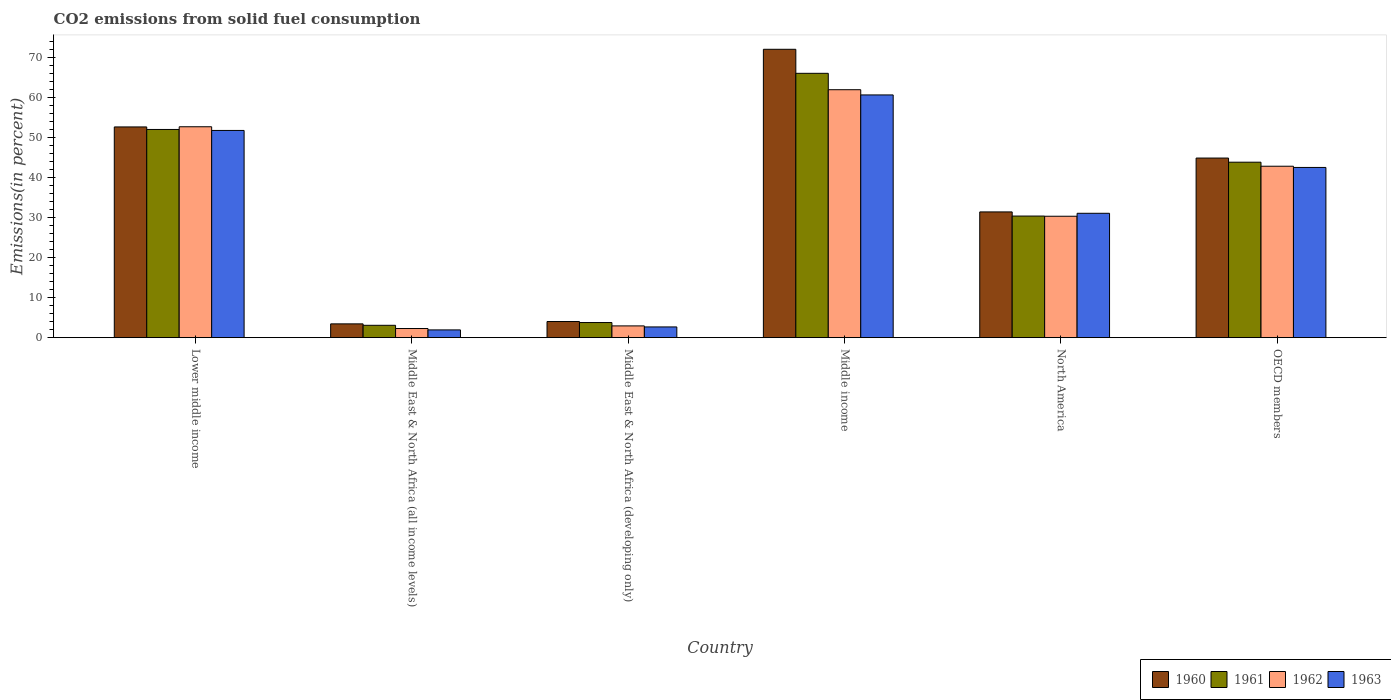How many different coloured bars are there?
Your answer should be very brief. 4. How many groups of bars are there?
Provide a short and direct response. 6. How many bars are there on the 5th tick from the left?
Provide a succinct answer. 4. How many bars are there on the 1st tick from the right?
Your response must be concise. 4. What is the label of the 5th group of bars from the left?
Provide a short and direct response. North America. In how many cases, is the number of bars for a given country not equal to the number of legend labels?
Make the answer very short. 0. What is the total CO2 emitted in 1962 in Middle income?
Make the answer very short. 61.92. Across all countries, what is the maximum total CO2 emitted in 1960?
Offer a very short reply. 72.02. Across all countries, what is the minimum total CO2 emitted in 1960?
Provide a succinct answer. 3.44. In which country was the total CO2 emitted in 1963 minimum?
Ensure brevity in your answer.  Middle East & North Africa (all income levels). What is the total total CO2 emitted in 1961 in the graph?
Ensure brevity in your answer.  199.06. What is the difference between the total CO2 emitted in 1960 in Lower middle income and that in North America?
Make the answer very short. 21.22. What is the difference between the total CO2 emitted in 1962 in Lower middle income and the total CO2 emitted in 1961 in North America?
Make the answer very short. 22.3. What is the average total CO2 emitted in 1961 per country?
Your answer should be compact. 33.18. What is the difference between the total CO2 emitted of/in 1963 and total CO2 emitted of/in 1962 in North America?
Your answer should be very brief. 0.74. In how many countries, is the total CO2 emitted in 1963 greater than 58 %?
Keep it short and to the point. 1. What is the ratio of the total CO2 emitted in 1963 in Middle East & North Africa (all income levels) to that in Middle income?
Your response must be concise. 0.03. Is the total CO2 emitted in 1962 in Lower middle income less than that in OECD members?
Offer a terse response. No. Is the difference between the total CO2 emitted in 1963 in Lower middle income and Middle East & North Africa (all income levels) greater than the difference between the total CO2 emitted in 1962 in Lower middle income and Middle East & North Africa (all income levels)?
Your response must be concise. No. What is the difference between the highest and the second highest total CO2 emitted in 1960?
Your response must be concise. 19.39. What is the difference between the highest and the lowest total CO2 emitted in 1961?
Give a very brief answer. 62.93. Is the sum of the total CO2 emitted in 1961 in Middle income and OECD members greater than the maximum total CO2 emitted in 1960 across all countries?
Ensure brevity in your answer.  Yes. What does the 2nd bar from the left in Lower middle income represents?
Your response must be concise. 1961. What does the 2nd bar from the right in OECD members represents?
Provide a short and direct response. 1962. How many bars are there?
Your answer should be very brief. 24. Are all the bars in the graph horizontal?
Give a very brief answer. No. How many countries are there in the graph?
Provide a short and direct response. 6. What is the difference between two consecutive major ticks on the Y-axis?
Keep it short and to the point. 10. How are the legend labels stacked?
Provide a succinct answer. Horizontal. What is the title of the graph?
Ensure brevity in your answer.  CO2 emissions from solid fuel consumption. What is the label or title of the X-axis?
Offer a very short reply. Country. What is the label or title of the Y-axis?
Give a very brief answer. Emissions(in percent). What is the Emissions(in percent) of 1960 in Lower middle income?
Your answer should be compact. 52.63. What is the Emissions(in percent) in 1961 in Lower middle income?
Your answer should be very brief. 51.99. What is the Emissions(in percent) of 1962 in Lower middle income?
Offer a terse response. 52.67. What is the Emissions(in percent) of 1963 in Lower middle income?
Give a very brief answer. 51.75. What is the Emissions(in percent) of 1960 in Middle East & North Africa (all income levels)?
Your answer should be very brief. 3.44. What is the Emissions(in percent) in 1961 in Middle East & North Africa (all income levels)?
Make the answer very short. 3.09. What is the Emissions(in percent) of 1962 in Middle East & North Africa (all income levels)?
Offer a terse response. 2.28. What is the Emissions(in percent) of 1963 in Middle East & North Africa (all income levels)?
Ensure brevity in your answer.  1.94. What is the Emissions(in percent) of 1960 in Middle East & North Africa (developing only)?
Provide a short and direct response. 4.03. What is the Emissions(in percent) of 1961 in Middle East & North Africa (developing only)?
Give a very brief answer. 3.78. What is the Emissions(in percent) in 1962 in Middle East & North Africa (developing only)?
Provide a succinct answer. 2.94. What is the Emissions(in percent) of 1963 in Middle East & North Africa (developing only)?
Offer a very short reply. 2.68. What is the Emissions(in percent) of 1960 in Middle income?
Your answer should be compact. 72.02. What is the Emissions(in percent) of 1961 in Middle income?
Provide a short and direct response. 66.02. What is the Emissions(in percent) in 1962 in Middle income?
Keep it short and to the point. 61.92. What is the Emissions(in percent) of 1963 in Middle income?
Your answer should be very brief. 60.62. What is the Emissions(in percent) of 1960 in North America?
Give a very brief answer. 31.4. What is the Emissions(in percent) of 1961 in North America?
Provide a short and direct response. 30.37. What is the Emissions(in percent) in 1962 in North America?
Make the answer very short. 30.32. What is the Emissions(in percent) in 1963 in North America?
Provide a short and direct response. 31.06. What is the Emissions(in percent) of 1960 in OECD members?
Offer a very short reply. 44.86. What is the Emissions(in percent) of 1961 in OECD members?
Make the answer very short. 43.82. What is the Emissions(in percent) in 1962 in OECD members?
Offer a terse response. 42.82. What is the Emissions(in percent) in 1963 in OECD members?
Your answer should be compact. 42.51. Across all countries, what is the maximum Emissions(in percent) in 1960?
Offer a terse response. 72.02. Across all countries, what is the maximum Emissions(in percent) of 1961?
Provide a short and direct response. 66.02. Across all countries, what is the maximum Emissions(in percent) of 1962?
Offer a terse response. 61.92. Across all countries, what is the maximum Emissions(in percent) in 1963?
Ensure brevity in your answer.  60.62. Across all countries, what is the minimum Emissions(in percent) of 1960?
Keep it short and to the point. 3.44. Across all countries, what is the minimum Emissions(in percent) in 1961?
Keep it short and to the point. 3.09. Across all countries, what is the minimum Emissions(in percent) in 1962?
Give a very brief answer. 2.28. Across all countries, what is the minimum Emissions(in percent) of 1963?
Your answer should be very brief. 1.94. What is the total Emissions(in percent) of 1960 in the graph?
Ensure brevity in your answer.  208.38. What is the total Emissions(in percent) of 1961 in the graph?
Provide a succinct answer. 199.06. What is the total Emissions(in percent) of 1962 in the graph?
Offer a terse response. 192.96. What is the total Emissions(in percent) in 1963 in the graph?
Provide a short and direct response. 190.56. What is the difference between the Emissions(in percent) in 1960 in Lower middle income and that in Middle East & North Africa (all income levels)?
Your answer should be very brief. 49.18. What is the difference between the Emissions(in percent) in 1961 in Lower middle income and that in Middle East & North Africa (all income levels)?
Your answer should be compact. 48.91. What is the difference between the Emissions(in percent) of 1962 in Lower middle income and that in Middle East & North Africa (all income levels)?
Your answer should be compact. 50.39. What is the difference between the Emissions(in percent) of 1963 in Lower middle income and that in Middle East & North Africa (all income levels)?
Your response must be concise. 49.81. What is the difference between the Emissions(in percent) in 1960 in Lower middle income and that in Middle East & North Africa (developing only)?
Your answer should be very brief. 48.6. What is the difference between the Emissions(in percent) of 1961 in Lower middle income and that in Middle East & North Africa (developing only)?
Keep it short and to the point. 48.22. What is the difference between the Emissions(in percent) of 1962 in Lower middle income and that in Middle East & North Africa (developing only)?
Make the answer very short. 49.73. What is the difference between the Emissions(in percent) in 1963 in Lower middle income and that in Middle East & North Africa (developing only)?
Provide a short and direct response. 49.07. What is the difference between the Emissions(in percent) in 1960 in Lower middle income and that in Middle income?
Provide a short and direct response. -19.39. What is the difference between the Emissions(in percent) of 1961 in Lower middle income and that in Middle income?
Make the answer very short. -14.02. What is the difference between the Emissions(in percent) of 1962 in Lower middle income and that in Middle income?
Provide a succinct answer. -9.25. What is the difference between the Emissions(in percent) of 1963 in Lower middle income and that in Middle income?
Your answer should be very brief. -8.87. What is the difference between the Emissions(in percent) of 1960 in Lower middle income and that in North America?
Your response must be concise. 21.22. What is the difference between the Emissions(in percent) of 1961 in Lower middle income and that in North America?
Offer a very short reply. 21.63. What is the difference between the Emissions(in percent) in 1962 in Lower middle income and that in North America?
Keep it short and to the point. 22.35. What is the difference between the Emissions(in percent) of 1963 in Lower middle income and that in North America?
Ensure brevity in your answer.  20.69. What is the difference between the Emissions(in percent) of 1960 in Lower middle income and that in OECD members?
Make the answer very short. 7.77. What is the difference between the Emissions(in percent) of 1961 in Lower middle income and that in OECD members?
Offer a terse response. 8.17. What is the difference between the Emissions(in percent) of 1962 in Lower middle income and that in OECD members?
Ensure brevity in your answer.  9.86. What is the difference between the Emissions(in percent) of 1963 in Lower middle income and that in OECD members?
Provide a succinct answer. 9.24. What is the difference between the Emissions(in percent) in 1960 in Middle East & North Africa (all income levels) and that in Middle East & North Africa (developing only)?
Provide a short and direct response. -0.59. What is the difference between the Emissions(in percent) of 1961 in Middle East & North Africa (all income levels) and that in Middle East & North Africa (developing only)?
Make the answer very short. -0.69. What is the difference between the Emissions(in percent) of 1962 in Middle East & North Africa (all income levels) and that in Middle East & North Africa (developing only)?
Your response must be concise. -0.65. What is the difference between the Emissions(in percent) of 1963 in Middle East & North Africa (all income levels) and that in Middle East & North Africa (developing only)?
Your answer should be very brief. -0.74. What is the difference between the Emissions(in percent) of 1960 in Middle East & North Africa (all income levels) and that in Middle income?
Offer a terse response. -68.57. What is the difference between the Emissions(in percent) of 1961 in Middle East & North Africa (all income levels) and that in Middle income?
Your response must be concise. -62.93. What is the difference between the Emissions(in percent) of 1962 in Middle East & North Africa (all income levels) and that in Middle income?
Give a very brief answer. -59.64. What is the difference between the Emissions(in percent) in 1963 in Middle East & North Africa (all income levels) and that in Middle income?
Keep it short and to the point. -58.68. What is the difference between the Emissions(in percent) of 1960 in Middle East & North Africa (all income levels) and that in North America?
Your answer should be compact. -27.96. What is the difference between the Emissions(in percent) of 1961 in Middle East & North Africa (all income levels) and that in North America?
Offer a terse response. -27.28. What is the difference between the Emissions(in percent) in 1962 in Middle East & North Africa (all income levels) and that in North America?
Your response must be concise. -28.04. What is the difference between the Emissions(in percent) in 1963 in Middle East & North Africa (all income levels) and that in North America?
Offer a terse response. -29.12. What is the difference between the Emissions(in percent) of 1960 in Middle East & North Africa (all income levels) and that in OECD members?
Your answer should be very brief. -41.41. What is the difference between the Emissions(in percent) of 1961 in Middle East & North Africa (all income levels) and that in OECD members?
Offer a terse response. -40.74. What is the difference between the Emissions(in percent) in 1962 in Middle East & North Africa (all income levels) and that in OECD members?
Keep it short and to the point. -40.53. What is the difference between the Emissions(in percent) in 1963 in Middle East & North Africa (all income levels) and that in OECD members?
Provide a short and direct response. -40.57. What is the difference between the Emissions(in percent) in 1960 in Middle East & North Africa (developing only) and that in Middle income?
Ensure brevity in your answer.  -67.99. What is the difference between the Emissions(in percent) of 1961 in Middle East & North Africa (developing only) and that in Middle income?
Offer a very short reply. -62.24. What is the difference between the Emissions(in percent) in 1962 in Middle East & North Africa (developing only) and that in Middle income?
Make the answer very short. -58.99. What is the difference between the Emissions(in percent) of 1963 in Middle East & North Africa (developing only) and that in Middle income?
Your answer should be very brief. -57.94. What is the difference between the Emissions(in percent) in 1960 in Middle East & North Africa (developing only) and that in North America?
Provide a succinct answer. -27.37. What is the difference between the Emissions(in percent) of 1961 in Middle East & North Africa (developing only) and that in North America?
Offer a terse response. -26.59. What is the difference between the Emissions(in percent) in 1962 in Middle East & North Africa (developing only) and that in North America?
Ensure brevity in your answer.  -27.38. What is the difference between the Emissions(in percent) in 1963 in Middle East & North Africa (developing only) and that in North America?
Offer a very short reply. -28.38. What is the difference between the Emissions(in percent) of 1960 in Middle East & North Africa (developing only) and that in OECD members?
Provide a succinct answer. -40.82. What is the difference between the Emissions(in percent) in 1961 in Middle East & North Africa (developing only) and that in OECD members?
Your answer should be compact. -40.05. What is the difference between the Emissions(in percent) of 1962 in Middle East & North Africa (developing only) and that in OECD members?
Your response must be concise. -39.88. What is the difference between the Emissions(in percent) in 1963 in Middle East & North Africa (developing only) and that in OECD members?
Give a very brief answer. -39.83. What is the difference between the Emissions(in percent) of 1960 in Middle income and that in North America?
Your answer should be very brief. 40.61. What is the difference between the Emissions(in percent) in 1961 in Middle income and that in North America?
Provide a short and direct response. 35.65. What is the difference between the Emissions(in percent) of 1962 in Middle income and that in North America?
Provide a short and direct response. 31.6. What is the difference between the Emissions(in percent) of 1963 in Middle income and that in North America?
Your answer should be very brief. 29.56. What is the difference between the Emissions(in percent) of 1960 in Middle income and that in OECD members?
Your response must be concise. 27.16. What is the difference between the Emissions(in percent) in 1961 in Middle income and that in OECD members?
Your answer should be compact. 22.2. What is the difference between the Emissions(in percent) in 1962 in Middle income and that in OECD members?
Offer a very short reply. 19.11. What is the difference between the Emissions(in percent) in 1963 in Middle income and that in OECD members?
Offer a very short reply. 18.11. What is the difference between the Emissions(in percent) in 1960 in North America and that in OECD members?
Provide a short and direct response. -13.45. What is the difference between the Emissions(in percent) of 1961 in North America and that in OECD members?
Give a very brief answer. -13.45. What is the difference between the Emissions(in percent) of 1962 in North America and that in OECD members?
Provide a succinct answer. -12.49. What is the difference between the Emissions(in percent) of 1963 in North America and that in OECD members?
Keep it short and to the point. -11.45. What is the difference between the Emissions(in percent) of 1960 in Lower middle income and the Emissions(in percent) of 1961 in Middle East & North Africa (all income levels)?
Give a very brief answer. 49.54. What is the difference between the Emissions(in percent) of 1960 in Lower middle income and the Emissions(in percent) of 1962 in Middle East & North Africa (all income levels)?
Provide a short and direct response. 50.34. What is the difference between the Emissions(in percent) of 1960 in Lower middle income and the Emissions(in percent) of 1963 in Middle East & North Africa (all income levels)?
Your response must be concise. 50.69. What is the difference between the Emissions(in percent) in 1961 in Lower middle income and the Emissions(in percent) in 1962 in Middle East & North Africa (all income levels)?
Your response must be concise. 49.71. What is the difference between the Emissions(in percent) of 1961 in Lower middle income and the Emissions(in percent) of 1963 in Middle East & North Africa (all income levels)?
Keep it short and to the point. 50.06. What is the difference between the Emissions(in percent) in 1962 in Lower middle income and the Emissions(in percent) in 1963 in Middle East & North Africa (all income levels)?
Offer a very short reply. 50.74. What is the difference between the Emissions(in percent) of 1960 in Lower middle income and the Emissions(in percent) of 1961 in Middle East & North Africa (developing only)?
Ensure brevity in your answer.  48.85. What is the difference between the Emissions(in percent) of 1960 in Lower middle income and the Emissions(in percent) of 1962 in Middle East & North Africa (developing only)?
Your answer should be very brief. 49.69. What is the difference between the Emissions(in percent) of 1960 in Lower middle income and the Emissions(in percent) of 1963 in Middle East & North Africa (developing only)?
Provide a short and direct response. 49.95. What is the difference between the Emissions(in percent) in 1961 in Lower middle income and the Emissions(in percent) in 1962 in Middle East & North Africa (developing only)?
Provide a succinct answer. 49.06. What is the difference between the Emissions(in percent) in 1961 in Lower middle income and the Emissions(in percent) in 1963 in Middle East & North Africa (developing only)?
Make the answer very short. 49.32. What is the difference between the Emissions(in percent) in 1962 in Lower middle income and the Emissions(in percent) in 1963 in Middle East & North Africa (developing only)?
Provide a succinct answer. 49.99. What is the difference between the Emissions(in percent) of 1960 in Lower middle income and the Emissions(in percent) of 1961 in Middle income?
Your answer should be compact. -13.39. What is the difference between the Emissions(in percent) of 1960 in Lower middle income and the Emissions(in percent) of 1962 in Middle income?
Provide a succinct answer. -9.3. What is the difference between the Emissions(in percent) of 1960 in Lower middle income and the Emissions(in percent) of 1963 in Middle income?
Offer a terse response. -7.99. What is the difference between the Emissions(in percent) in 1961 in Lower middle income and the Emissions(in percent) in 1962 in Middle income?
Offer a terse response. -9.93. What is the difference between the Emissions(in percent) of 1961 in Lower middle income and the Emissions(in percent) of 1963 in Middle income?
Offer a terse response. -8.62. What is the difference between the Emissions(in percent) of 1962 in Lower middle income and the Emissions(in percent) of 1963 in Middle income?
Provide a succinct answer. -7.95. What is the difference between the Emissions(in percent) of 1960 in Lower middle income and the Emissions(in percent) of 1961 in North America?
Give a very brief answer. 22.26. What is the difference between the Emissions(in percent) in 1960 in Lower middle income and the Emissions(in percent) in 1962 in North America?
Provide a succinct answer. 22.31. What is the difference between the Emissions(in percent) of 1960 in Lower middle income and the Emissions(in percent) of 1963 in North America?
Provide a short and direct response. 21.57. What is the difference between the Emissions(in percent) in 1961 in Lower middle income and the Emissions(in percent) in 1962 in North America?
Your response must be concise. 21.67. What is the difference between the Emissions(in percent) in 1961 in Lower middle income and the Emissions(in percent) in 1963 in North America?
Keep it short and to the point. 20.93. What is the difference between the Emissions(in percent) of 1962 in Lower middle income and the Emissions(in percent) of 1963 in North America?
Keep it short and to the point. 21.61. What is the difference between the Emissions(in percent) of 1960 in Lower middle income and the Emissions(in percent) of 1961 in OECD members?
Keep it short and to the point. 8.8. What is the difference between the Emissions(in percent) of 1960 in Lower middle income and the Emissions(in percent) of 1962 in OECD members?
Your response must be concise. 9.81. What is the difference between the Emissions(in percent) in 1960 in Lower middle income and the Emissions(in percent) in 1963 in OECD members?
Ensure brevity in your answer.  10.12. What is the difference between the Emissions(in percent) in 1961 in Lower middle income and the Emissions(in percent) in 1962 in OECD members?
Your response must be concise. 9.18. What is the difference between the Emissions(in percent) of 1961 in Lower middle income and the Emissions(in percent) of 1963 in OECD members?
Give a very brief answer. 9.48. What is the difference between the Emissions(in percent) of 1962 in Lower middle income and the Emissions(in percent) of 1963 in OECD members?
Provide a succinct answer. 10.16. What is the difference between the Emissions(in percent) of 1960 in Middle East & North Africa (all income levels) and the Emissions(in percent) of 1961 in Middle East & North Africa (developing only)?
Keep it short and to the point. -0.33. What is the difference between the Emissions(in percent) in 1960 in Middle East & North Africa (all income levels) and the Emissions(in percent) in 1962 in Middle East & North Africa (developing only)?
Provide a short and direct response. 0.51. What is the difference between the Emissions(in percent) in 1960 in Middle East & North Africa (all income levels) and the Emissions(in percent) in 1963 in Middle East & North Africa (developing only)?
Give a very brief answer. 0.76. What is the difference between the Emissions(in percent) of 1961 in Middle East & North Africa (all income levels) and the Emissions(in percent) of 1962 in Middle East & North Africa (developing only)?
Keep it short and to the point. 0.15. What is the difference between the Emissions(in percent) of 1961 in Middle East & North Africa (all income levels) and the Emissions(in percent) of 1963 in Middle East & North Africa (developing only)?
Your response must be concise. 0.41. What is the difference between the Emissions(in percent) of 1962 in Middle East & North Africa (all income levels) and the Emissions(in percent) of 1963 in Middle East & North Africa (developing only)?
Keep it short and to the point. -0.4. What is the difference between the Emissions(in percent) in 1960 in Middle East & North Africa (all income levels) and the Emissions(in percent) in 1961 in Middle income?
Make the answer very short. -62.57. What is the difference between the Emissions(in percent) in 1960 in Middle East & North Africa (all income levels) and the Emissions(in percent) in 1962 in Middle income?
Provide a succinct answer. -58.48. What is the difference between the Emissions(in percent) in 1960 in Middle East & North Africa (all income levels) and the Emissions(in percent) in 1963 in Middle income?
Your response must be concise. -57.18. What is the difference between the Emissions(in percent) of 1961 in Middle East & North Africa (all income levels) and the Emissions(in percent) of 1962 in Middle income?
Provide a short and direct response. -58.84. What is the difference between the Emissions(in percent) in 1961 in Middle East & North Africa (all income levels) and the Emissions(in percent) in 1963 in Middle income?
Your response must be concise. -57.53. What is the difference between the Emissions(in percent) in 1962 in Middle East & North Africa (all income levels) and the Emissions(in percent) in 1963 in Middle income?
Provide a succinct answer. -58.34. What is the difference between the Emissions(in percent) of 1960 in Middle East & North Africa (all income levels) and the Emissions(in percent) of 1961 in North America?
Keep it short and to the point. -26.92. What is the difference between the Emissions(in percent) of 1960 in Middle East & North Africa (all income levels) and the Emissions(in percent) of 1962 in North America?
Offer a terse response. -26.88. What is the difference between the Emissions(in percent) in 1960 in Middle East & North Africa (all income levels) and the Emissions(in percent) in 1963 in North America?
Your answer should be compact. -27.62. What is the difference between the Emissions(in percent) in 1961 in Middle East & North Africa (all income levels) and the Emissions(in percent) in 1962 in North America?
Your answer should be very brief. -27.24. What is the difference between the Emissions(in percent) of 1961 in Middle East & North Africa (all income levels) and the Emissions(in percent) of 1963 in North America?
Provide a succinct answer. -27.98. What is the difference between the Emissions(in percent) of 1962 in Middle East & North Africa (all income levels) and the Emissions(in percent) of 1963 in North America?
Keep it short and to the point. -28.78. What is the difference between the Emissions(in percent) of 1960 in Middle East & North Africa (all income levels) and the Emissions(in percent) of 1961 in OECD members?
Provide a short and direct response. -40.38. What is the difference between the Emissions(in percent) of 1960 in Middle East & North Africa (all income levels) and the Emissions(in percent) of 1962 in OECD members?
Your answer should be compact. -39.37. What is the difference between the Emissions(in percent) of 1960 in Middle East & North Africa (all income levels) and the Emissions(in percent) of 1963 in OECD members?
Your answer should be very brief. -39.07. What is the difference between the Emissions(in percent) in 1961 in Middle East & North Africa (all income levels) and the Emissions(in percent) in 1962 in OECD members?
Offer a very short reply. -39.73. What is the difference between the Emissions(in percent) in 1961 in Middle East & North Africa (all income levels) and the Emissions(in percent) in 1963 in OECD members?
Your response must be concise. -39.43. What is the difference between the Emissions(in percent) of 1962 in Middle East & North Africa (all income levels) and the Emissions(in percent) of 1963 in OECD members?
Keep it short and to the point. -40.23. What is the difference between the Emissions(in percent) of 1960 in Middle East & North Africa (developing only) and the Emissions(in percent) of 1961 in Middle income?
Your answer should be very brief. -61.99. What is the difference between the Emissions(in percent) in 1960 in Middle East & North Africa (developing only) and the Emissions(in percent) in 1962 in Middle income?
Offer a very short reply. -57.89. What is the difference between the Emissions(in percent) of 1960 in Middle East & North Africa (developing only) and the Emissions(in percent) of 1963 in Middle income?
Offer a very short reply. -56.59. What is the difference between the Emissions(in percent) in 1961 in Middle East & North Africa (developing only) and the Emissions(in percent) in 1962 in Middle income?
Provide a short and direct response. -58.15. What is the difference between the Emissions(in percent) of 1961 in Middle East & North Africa (developing only) and the Emissions(in percent) of 1963 in Middle income?
Ensure brevity in your answer.  -56.84. What is the difference between the Emissions(in percent) in 1962 in Middle East & North Africa (developing only) and the Emissions(in percent) in 1963 in Middle income?
Provide a succinct answer. -57.68. What is the difference between the Emissions(in percent) in 1960 in Middle East & North Africa (developing only) and the Emissions(in percent) in 1961 in North America?
Make the answer very short. -26.34. What is the difference between the Emissions(in percent) in 1960 in Middle East & North Africa (developing only) and the Emissions(in percent) in 1962 in North America?
Your response must be concise. -26.29. What is the difference between the Emissions(in percent) of 1960 in Middle East & North Africa (developing only) and the Emissions(in percent) of 1963 in North America?
Your response must be concise. -27.03. What is the difference between the Emissions(in percent) in 1961 in Middle East & North Africa (developing only) and the Emissions(in percent) in 1962 in North America?
Ensure brevity in your answer.  -26.55. What is the difference between the Emissions(in percent) of 1961 in Middle East & North Africa (developing only) and the Emissions(in percent) of 1963 in North America?
Make the answer very short. -27.28. What is the difference between the Emissions(in percent) of 1962 in Middle East & North Africa (developing only) and the Emissions(in percent) of 1963 in North America?
Your response must be concise. -28.12. What is the difference between the Emissions(in percent) in 1960 in Middle East & North Africa (developing only) and the Emissions(in percent) in 1961 in OECD members?
Offer a very short reply. -39.79. What is the difference between the Emissions(in percent) in 1960 in Middle East & North Africa (developing only) and the Emissions(in percent) in 1962 in OECD members?
Offer a terse response. -38.79. What is the difference between the Emissions(in percent) of 1960 in Middle East & North Africa (developing only) and the Emissions(in percent) of 1963 in OECD members?
Your answer should be compact. -38.48. What is the difference between the Emissions(in percent) of 1961 in Middle East & North Africa (developing only) and the Emissions(in percent) of 1962 in OECD members?
Provide a short and direct response. -39.04. What is the difference between the Emissions(in percent) in 1961 in Middle East & North Africa (developing only) and the Emissions(in percent) in 1963 in OECD members?
Your response must be concise. -38.74. What is the difference between the Emissions(in percent) of 1962 in Middle East & North Africa (developing only) and the Emissions(in percent) of 1963 in OECD members?
Ensure brevity in your answer.  -39.57. What is the difference between the Emissions(in percent) of 1960 in Middle income and the Emissions(in percent) of 1961 in North America?
Your response must be concise. 41.65. What is the difference between the Emissions(in percent) of 1960 in Middle income and the Emissions(in percent) of 1962 in North America?
Your answer should be very brief. 41.7. What is the difference between the Emissions(in percent) of 1960 in Middle income and the Emissions(in percent) of 1963 in North America?
Make the answer very short. 40.96. What is the difference between the Emissions(in percent) of 1961 in Middle income and the Emissions(in percent) of 1962 in North America?
Keep it short and to the point. 35.7. What is the difference between the Emissions(in percent) in 1961 in Middle income and the Emissions(in percent) in 1963 in North America?
Provide a short and direct response. 34.96. What is the difference between the Emissions(in percent) in 1962 in Middle income and the Emissions(in percent) in 1963 in North America?
Give a very brief answer. 30.86. What is the difference between the Emissions(in percent) of 1960 in Middle income and the Emissions(in percent) of 1961 in OECD members?
Keep it short and to the point. 28.2. What is the difference between the Emissions(in percent) in 1960 in Middle income and the Emissions(in percent) in 1962 in OECD members?
Ensure brevity in your answer.  29.2. What is the difference between the Emissions(in percent) in 1960 in Middle income and the Emissions(in percent) in 1963 in OECD members?
Your answer should be very brief. 29.51. What is the difference between the Emissions(in percent) of 1961 in Middle income and the Emissions(in percent) of 1962 in OECD members?
Provide a short and direct response. 23.2. What is the difference between the Emissions(in percent) of 1961 in Middle income and the Emissions(in percent) of 1963 in OECD members?
Provide a succinct answer. 23.51. What is the difference between the Emissions(in percent) in 1962 in Middle income and the Emissions(in percent) in 1963 in OECD members?
Give a very brief answer. 19.41. What is the difference between the Emissions(in percent) in 1960 in North America and the Emissions(in percent) in 1961 in OECD members?
Provide a succinct answer. -12.42. What is the difference between the Emissions(in percent) of 1960 in North America and the Emissions(in percent) of 1962 in OECD members?
Offer a terse response. -11.41. What is the difference between the Emissions(in percent) in 1960 in North America and the Emissions(in percent) in 1963 in OECD members?
Make the answer very short. -11.11. What is the difference between the Emissions(in percent) in 1961 in North America and the Emissions(in percent) in 1962 in OECD members?
Provide a succinct answer. -12.45. What is the difference between the Emissions(in percent) in 1961 in North America and the Emissions(in percent) in 1963 in OECD members?
Your answer should be very brief. -12.14. What is the difference between the Emissions(in percent) in 1962 in North America and the Emissions(in percent) in 1963 in OECD members?
Provide a succinct answer. -12.19. What is the average Emissions(in percent) in 1960 per country?
Give a very brief answer. 34.73. What is the average Emissions(in percent) in 1961 per country?
Provide a succinct answer. 33.18. What is the average Emissions(in percent) of 1962 per country?
Ensure brevity in your answer.  32.16. What is the average Emissions(in percent) of 1963 per country?
Offer a very short reply. 31.76. What is the difference between the Emissions(in percent) in 1960 and Emissions(in percent) in 1961 in Lower middle income?
Provide a short and direct response. 0.63. What is the difference between the Emissions(in percent) in 1960 and Emissions(in percent) in 1962 in Lower middle income?
Offer a very short reply. -0.05. What is the difference between the Emissions(in percent) in 1960 and Emissions(in percent) in 1963 in Lower middle income?
Your response must be concise. 0.88. What is the difference between the Emissions(in percent) of 1961 and Emissions(in percent) of 1962 in Lower middle income?
Offer a very short reply. -0.68. What is the difference between the Emissions(in percent) in 1961 and Emissions(in percent) in 1963 in Lower middle income?
Provide a succinct answer. 0.24. What is the difference between the Emissions(in percent) in 1962 and Emissions(in percent) in 1963 in Lower middle income?
Your response must be concise. 0.92. What is the difference between the Emissions(in percent) in 1960 and Emissions(in percent) in 1961 in Middle East & North Africa (all income levels)?
Keep it short and to the point. 0.36. What is the difference between the Emissions(in percent) in 1960 and Emissions(in percent) in 1962 in Middle East & North Africa (all income levels)?
Your response must be concise. 1.16. What is the difference between the Emissions(in percent) of 1960 and Emissions(in percent) of 1963 in Middle East & North Africa (all income levels)?
Provide a succinct answer. 1.51. What is the difference between the Emissions(in percent) in 1961 and Emissions(in percent) in 1962 in Middle East & North Africa (all income levels)?
Provide a succinct answer. 0.8. What is the difference between the Emissions(in percent) of 1961 and Emissions(in percent) of 1963 in Middle East & North Africa (all income levels)?
Provide a succinct answer. 1.15. What is the difference between the Emissions(in percent) in 1962 and Emissions(in percent) in 1963 in Middle East & North Africa (all income levels)?
Your response must be concise. 0.35. What is the difference between the Emissions(in percent) in 1960 and Emissions(in percent) in 1961 in Middle East & North Africa (developing only)?
Offer a terse response. 0.25. What is the difference between the Emissions(in percent) in 1960 and Emissions(in percent) in 1962 in Middle East & North Africa (developing only)?
Your answer should be very brief. 1.09. What is the difference between the Emissions(in percent) in 1960 and Emissions(in percent) in 1963 in Middle East & North Africa (developing only)?
Ensure brevity in your answer.  1.35. What is the difference between the Emissions(in percent) in 1961 and Emissions(in percent) in 1962 in Middle East & North Africa (developing only)?
Provide a succinct answer. 0.84. What is the difference between the Emissions(in percent) of 1961 and Emissions(in percent) of 1963 in Middle East & North Africa (developing only)?
Offer a very short reply. 1.1. What is the difference between the Emissions(in percent) in 1962 and Emissions(in percent) in 1963 in Middle East & North Africa (developing only)?
Your answer should be compact. 0.26. What is the difference between the Emissions(in percent) of 1960 and Emissions(in percent) of 1961 in Middle income?
Your response must be concise. 6. What is the difference between the Emissions(in percent) of 1960 and Emissions(in percent) of 1962 in Middle income?
Keep it short and to the point. 10.09. What is the difference between the Emissions(in percent) of 1960 and Emissions(in percent) of 1963 in Middle income?
Provide a short and direct response. 11.4. What is the difference between the Emissions(in percent) in 1961 and Emissions(in percent) in 1962 in Middle income?
Provide a short and direct response. 4.09. What is the difference between the Emissions(in percent) of 1961 and Emissions(in percent) of 1963 in Middle income?
Provide a succinct answer. 5.4. What is the difference between the Emissions(in percent) in 1962 and Emissions(in percent) in 1963 in Middle income?
Offer a very short reply. 1.31. What is the difference between the Emissions(in percent) of 1960 and Emissions(in percent) of 1961 in North America?
Your answer should be very brief. 1.03. What is the difference between the Emissions(in percent) in 1960 and Emissions(in percent) in 1962 in North America?
Offer a very short reply. 1.08. What is the difference between the Emissions(in percent) of 1960 and Emissions(in percent) of 1963 in North America?
Provide a succinct answer. 0.34. What is the difference between the Emissions(in percent) in 1961 and Emissions(in percent) in 1962 in North America?
Provide a succinct answer. 0.05. What is the difference between the Emissions(in percent) in 1961 and Emissions(in percent) in 1963 in North America?
Offer a terse response. -0.69. What is the difference between the Emissions(in percent) of 1962 and Emissions(in percent) of 1963 in North America?
Provide a succinct answer. -0.74. What is the difference between the Emissions(in percent) of 1960 and Emissions(in percent) of 1961 in OECD members?
Give a very brief answer. 1.03. What is the difference between the Emissions(in percent) of 1960 and Emissions(in percent) of 1962 in OECD members?
Keep it short and to the point. 2.04. What is the difference between the Emissions(in percent) in 1960 and Emissions(in percent) in 1963 in OECD members?
Offer a very short reply. 2.34. What is the difference between the Emissions(in percent) in 1961 and Emissions(in percent) in 1962 in OECD members?
Your response must be concise. 1.01. What is the difference between the Emissions(in percent) of 1961 and Emissions(in percent) of 1963 in OECD members?
Your answer should be compact. 1.31. What is the difference between the Emissions(in percent) of 1962 and Emissions(in percent) of 1963 in OECD members?
Give a very brief answer. 0.3. What is the ratio of the Emissions(in percent) in 1960 in Lower middle income to that in Middle East & North Africa (all income levels)?
Provide a succinct answer. 15.28. What is the ratio of the Emissions(in percent) of 1961 in Lower middle income to that in Middle East & North Africa (all income levels)?
Your response must be concise. 16.85. What is the ratio of the Emissions(in percent) of 1962 in Lower middle income to that in Middle East & North Africa (all income levels)?
Ensure brevity in your answer.  23.07. What is the ratio of the Emissions(in percent) in 1963 in Lower middle income to that in Middle East & North Africa (all income levels)?
Give a very brief answer. 26.71. What is the ratio of the Emissions(in percent) of 1960 in Lower middle income to that in Middle East & North Africa (developing only)?
Your answer should be very brief. 13.06. What is the ratio of the Emissions(in percent) in 1961 in Lower middle income to that in Middle East & North Africa (developing only)?
Provide a succinct answer. 13.77. What is the ratio of the Emissions(in percent) in 1962 in Lower middle income to that in Middle East & North Africa (developing only)?
Your response must be concise. 17.93. What is the ratio of the Emissions(in percent) of 1963 in Lower middle income to that in Middle East & North Africa (developing only)?
Your answer should be very brief. 19.31. What is the ratio of the Emissions(in percent) in 1960 in Lower middle income to that in Middle income?
Provide a short and direct response. 0.73. What is the ratio of the Emissions(in percent) of 1961 in Lower middle income to that in Middle income?
Offer a terse response. 0.79. What is the ratio of the Emissions(in percent) of 1962 in Lower middle income to that in Middle income?
Offer a terse response. 0.85. What is the ratio of the Emissions(in percent) in 1963 in Lower middle income to that in Middle income?
Give a very brief answer. 0.85. What is the ratio of the Emissions(in percent) of 1960 in Lower middle income to that in North America?
Offer a very short reply. 1.68. What is the ratio of the Emissions(in percent) of 1961 in Lower middle income to that in North America?
Provide a short and direct response. 1.71. What is the ratio of the Emissions(in percent) in 1962 in Lower middle income to that in North America?
Provide a short and direct response. 1.74. What is the ratio of the Emissions(in percent) of 1963 in Lower middle income to that in North America?
Offer a terse response. 1.67. What is the ratio of the Emissions(in percent) in 1960 in Lower middle income to that in OECD members?
Your response must be concise. 1.17. What is the ratio of the Emissions(in percent) in 1961 in Lower middle income to that in OECD members?
Offer a terse response. 1.19. What is the ratio of the Emissions(in percent) in 1962 in Lower middle income to that in OECD members?
Give a very brief answer. 1.23. What is the ratio of the Emissions(in percent) of 1963 in Lower middle income to that in OECD members?
Ensure brevity in your answer.  1.22. What is the ratio of the Emissions(in percent) in 1960 in Middle East & North Africa (all income levels) to that in Middle East & North Africa (developing only)?
Ensure brevity in your answer.  0.85. What is the ratio of the Emissions(in percent) in 1961 in Middle East & North Africa (all income levels) to that in Middle East & North Africa (developing only)?
Keep it short and to the point. 0.82. What is the ratio of the Emissions(in percent) in 1962 in Middle East & North Africa (all income levels) to that in Middle East & North Africa (developing only)?
Make the answer very short. 0.78. What is the ratio of the Emissions(in percent) in 1963 in Middle East & North Africa (all income levels) to that in Middle East & North Africa (developing only)?
Provide a short and direct response. 0.72. What is the ratio of the Emissions(in percent) in 1960 in Middle East & North Africa (all income levels) to that in Middle income?
Provide a short and direct response. 0.05. What is the ratio of the Emissions(in percent) of 1961 in Middle East & North Africa (all income levels) to that in Middle income?
Make the answer very short. 0.05. What is the ratio of the Emissions(in percent) in 1962 in Middle East & North Africa (all income levels) to that in Middle income?
Give a very brief answer. 0.04. What is the ratio of the Emissions(in percent) of 1963 in Middle East & North Africa (all income levels) to that in Middle income?
Offer a very short reply. 0.03. What is the ratio of the Emissions(in percent) of 1960 in Middle East & North Africa (all income levels) to that in North America?
Provide a succinct answer. 0.11. What is the ratio of the Emissions(in percent) of 1961 in Middle East & North Africa (all income levels) to that in North America?
Keep it short and to the point. 0.1. What is the ratio of the Emissions(in percent) of 1962 in Middle East & North Africa (all income levels) to that in North America?
Your answer should be very brief. 0.08. What is the ratio of the Emissions(in percent) of 1963 in Middle East & North Africa (all income levels) to that in North America?
Offer a very short reply. 0.06. What is the ratio of the Emissions(in percent) of 1960 in Middle East & North Africa (all income levels) to that in OECD members?
Keep it short and to the point. 0.08. What is the ratio of the Emissions(in percent) of 1961 in Middle East & North Africa (all income levels) to that in OECD members?
Your response must be concise. 0.07. What is the ratio of the Emissions(in percent) of 1962 in Middle East & North Africa (all income levels) to that in OECD members?
Keep it short and to the point. 0.05. What is the ratio of the Emissions(in percent) in 1963 in Middle East & North Africa (all income levels) to that in OECD members?
Your answer should be compact. 0.05. What is the ratio of the Emissions(in percent) of 1960 in Middle East & North Africa (developing only) to that in Middle income?
Make the answer very short. 0.06. What is the ratio of the Emissions(in percent) in 1961 in Middle East & North Africa (developing only) to that in Middle income?
Your answer should be very brief. 0.06. What is the ratio of the Emissions(in percent) in 1962 in Middle East & North Africa (developing only) to that in Middle income?
Your answer should be compact. 0.05. What is the ratio of the Emissions(in percent) in 1963 in Middle East & North Africa (developing only) to that in Middle income?
Provide a short and direct response. 0.04. What is the ratio of the Emissions(in percent) of 1960 in Middle East & North Africa (developing only) to that in North America?
Provide a succinct answer. 0.13. What is the ratio of the Emissions(in percent) of 1961 in Middle East & North Africa (developing only) to that in North America?
Your answer should be compact. 0.12. What is the ratio of the Emissions(in percent) of 1962 in Middle East & North Africa (developing only) to that in North America?
Your answer should be very brief. 0.1. What is the ratio of the Emissions(in percent) of 1963 in Middle East & North Africa (developing only) to that in North America?
Your response must be concise. 0.09. What is the ratio of the Emissions(in percent) of 1960 in Middle East & North Africa (developing only) to that in OECD members?
Your answer should be compact. 0.09. What is the ratio of the Emissions(in percent) in 1961 in Middle East & North Africa (developing only) to that in OECD members?
Offer a terse response. 0.09. What is the ratio of the Emissions(in percent) in 1962 in Middle East & North Africa (developing only) to that in OECD members?
Ensure brevity in your answer.  0.07. What is the ratio of the Emissions(in percent) in 1963 in Middle East & North Africa (developing only) to that in OECD members?
Offer a very short reply. 0.06. What is the ratio of the Emissions(in percent) in 1960 in Middle income to that in North America?
Make the answer very short. 2.29. What is the ratio of the Emissions(in percent) in 1961 in Middle income to that in North America?
Provide a short and direct response. 2.17. What is the ratio of the Emissions(in percent) in 1962 in Middle income to that in North America?
Keep it short and to the point. 2.04. What is the ratio of the Emissions(in percent) of 1963 in Middle income to that in North America?
Your response must be concise. 1.95. What is the ratio of the Emissions(in percent) of 1960 in Middle income to that in OECD members?
Your response must be concise. 1.61. What is the ratio of the Emissions(in percent) of 1961 in Middle income to that in OECD members?
Make the answer very short. 1.51. What is the ratio of the Emissions(in percent) in 1962 in Middle income to that in OECD members?
Your answer should be compact. 1.45. What is the ratio of the Emissions(in percent) in 1963 in Middle income to that in OECD members?
Ensure brevity in your answer.  1.43. What is the ratio of the Emissions(in percent) of 1960 in North America to that in OECD members?
Your response must be concise. 0.7. What is the ratio of the Emissions(in percent) in 1961 in North America to that in OECD members?
Your answer should be very brief. 0.69. What is the ratio of the Emissions(in percent) in 1962 in North America to that in OECD members?
Make the answer very short. 0.71. What is the ratio of the Emissions(in percent) in 1963 in North America to that in OECD members?
Ensure brevity in your answer.  0.73. What is the difference between the highest and the second highest Emissions(in percent) of 1960?
Your answer should be very brief. 19.39. What is the difference between the highest and the second highest Emissions(in percent) of 1961?
Give a very brief answer. 14.02. What is the difference between the highest and the second highest Emissions(in percent) in 1962?
Give a very brief answer. 9.25. What is the difference between the highest and the second highest Emissions(in percent) of 1963?
Make the answer very short. 8.87. What is the difference between the highest and the lowest Emissions(in percent) of 1960?
Offer a very short reply. 68.57. What is the difference between the highest and the lowest Emissions(in percent) of 1961?
Your answer should be compact. 62.93. What is the difference between the highest and the lowest Emissions(in percent) of 1962?
Give a very brief answer. 59.64. What is the difference between the highest and the lowest Emissions(in percent) of 1963?
Provide a short and direct response. 58.68. 